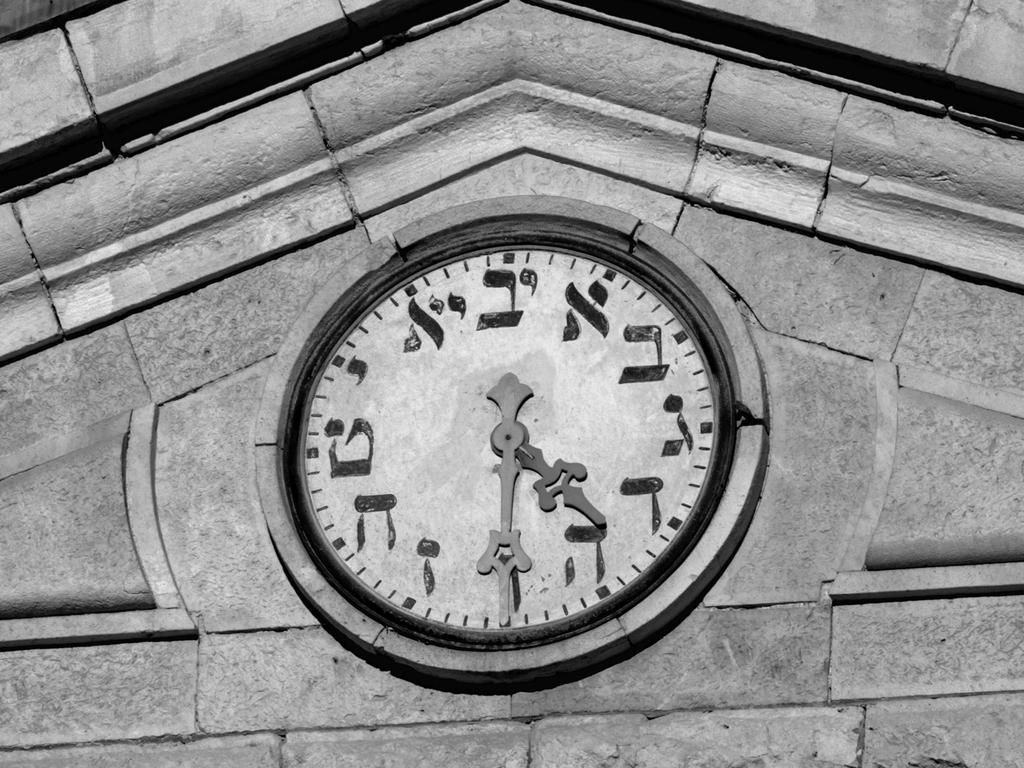What is the color scheme of the image? The image is black and white. What object can be seen on the wall in the image? There is a clock on the wall in the image. What type of chalk is being used during the meeting in the image? There is no meeting or chalk present in the image; it only features a black and white clock on the wall. 